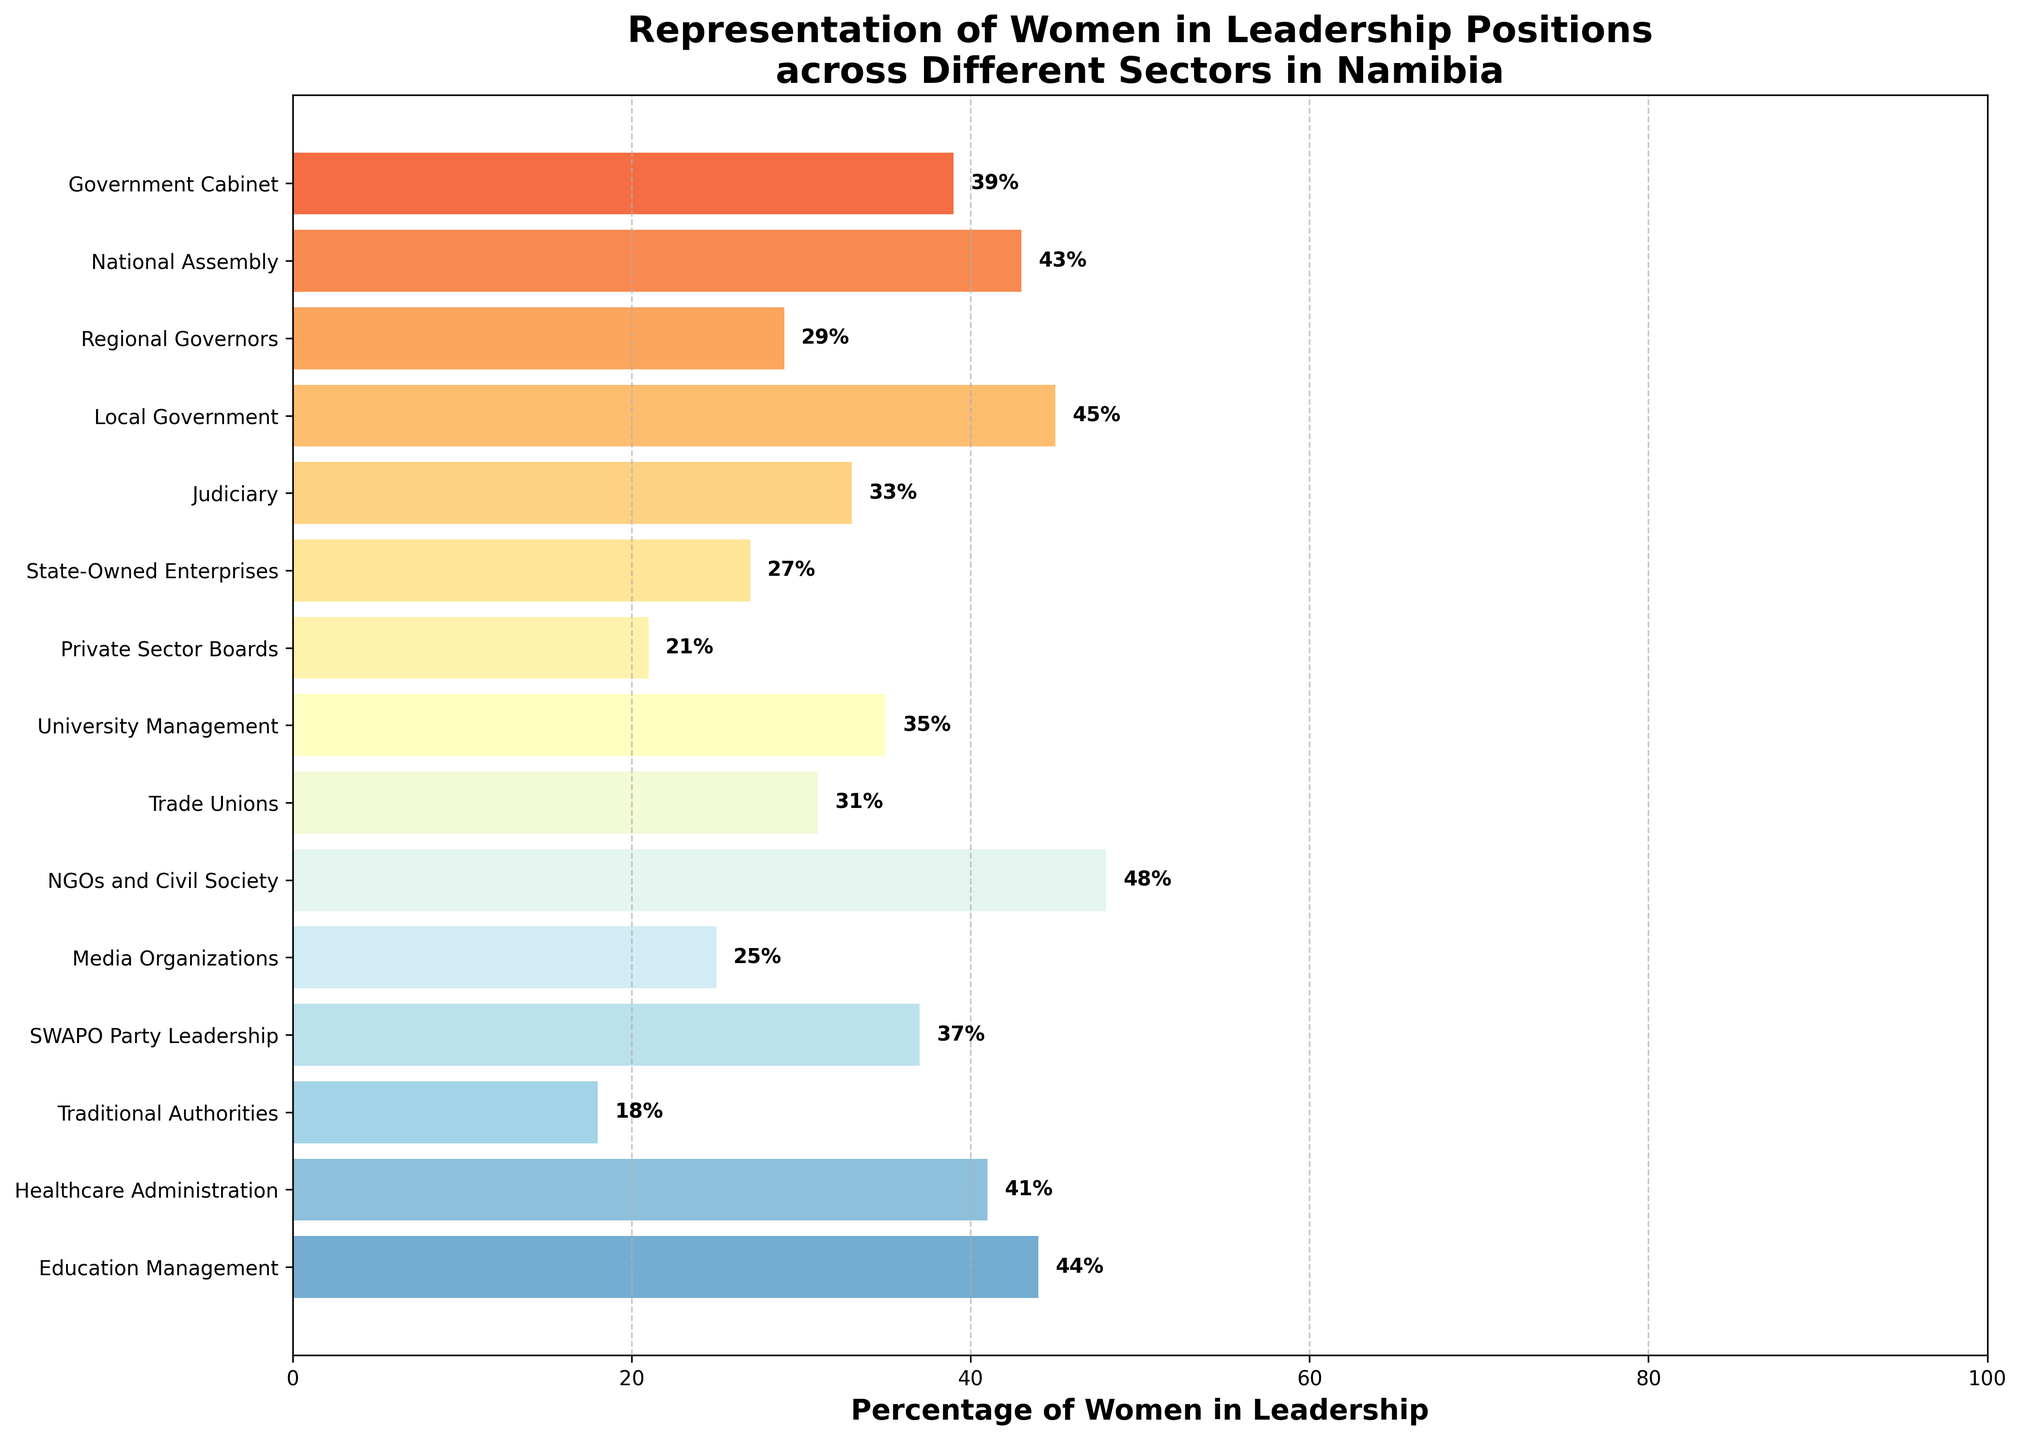Which sector has the highest percentage of women in leadership? The sector with the largest bar and highest percentage label has the highest percentage of women in leadership. In this case, it is NGOs and Civil Society with 48%.
Answer: NGOs and Civil Society Which sector has the lowest percentage of women in leadership? The shortest bar and smallest percentage label indicate the sector with the lowest representation. Here, it is Traditional Authorities with 18%.
Answer: Traditional Authorities Compare the percentage of women in SWAPO Party Leadership to that in Government Cabinet. Which is higher? By comparing the two bars visually and reading the percentage labels, SWAPO Party Leadership has 37% while Government Cabinet has 39%. Thus, Government Cabinet is higher.
Answer: Government Cabinet What is the average percentage of women in leadership across the sectors shown? Sum all the percentage values and divide by the number of sectors: (39 + 43 + 29 + 45 + 33 + 27 + 21 + 35 + 31 + 48 + 25 + 37 + 18 + 41 + 44) / 15 = 516 / 15 = 34.4%
Answer: 34.4% Which sector has a higher percentage of women in leadership, Judiciary or Private Sector Boards? Compare the two bars and their respective percentages. Judiciary has 33%, while Private Sector Boards have 21%. Thus, Judiciary is higher.
Answer: Judiciary What is the difference in the percentage of women in leadership between Education Management and Media Organizations? Subtract the percentage of Media Organizations from Education Management: 44 - 25 = 19%
Answer: 19% Identify the sectors with more than 40% women in leadership. Look at each bar and its percentage to find all those greater than 40%. They are Local Government (45%), NGOs and Civil Society (48%), Education Management (44%), and Healthcare Administration (41%).
Answer: Local Government, NGOs and Civil Society, Education Management, Healthcare Administration Is the percentage of women in leadership in State-Owned Enterprises closer to that in the Private Sector Boards or Judiciary? Compare the percentage of State-Owned Enterprises (27%) with both Private Sector Boards (21%) and Judiciary (33%). The difference with Private Sector Boards is 6% and with Judiciary is 6%, so it is equally close to both.
Answer: Equally close How does the percentage of women in leadership in Healthcare Administration compare to that in Education Management? Both the bars and their percentage labels show that Healthcare Administration has 41% and Education Management has 44%. Education Management is higher.
Answer: Education Management 